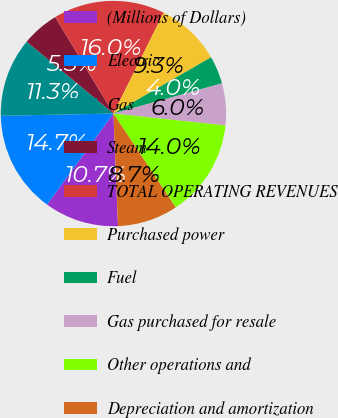Convert chart to OTSL. <chart><loc_0><loc_0><loc_500><loc_500><pie_chart><fcel>(Millions of Dollars)<fcel>Electric<fcel>Gas<fcel>Steam<fcel>TOTAL OPERATING REVENUES<fcel>Purchased power<fcel>Fuel<fcel>Gas purchased for resale<fcel>Other operations and<fcel>Depreciation and amortization<nl><fcel>10.67%<fcel>14.66%<fcel>11.33%<fcel>5.34%<fcel>16.0%<fcel>9.33%<fcel>4.0%<fcel>6.0%<fcel>14.0%<fcel>8.67%<nl></chart> 